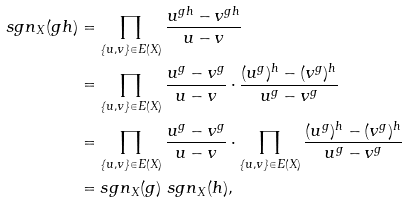Convert formula to latex. <formula><loc_0><loc_0><loc_500><loc_500>s g n _ { X } ( g h ) & = \prod _ { \{ u , v \} \in E ( X ) } \frac { u ^ { g h } - v ^ { g h } } { u - v } \\ & = \prod _ { \{ u , v \} \in E ( X ) } \frac { u ^ { g } - v ^ { g } } { u - v } \cdot \frac { ( u ^ { g } ) ^ { h } - ( v ^ { g } ) ^ { h } } { u ^ { g } - v ^ { g } } \\ & = \prod _ { \{ u , v \} \in E ( X ) } \frac { u ^ { g } - v ^ { g } } { u - v } \cdot \prod _ { \{ u , v \} \in E ( X ) } \frac { ( u ^ { g } ) ^ { h } - ( v ^ { g } ) ^ { h } } { u ^ { g } - v ^ { g } } \\ & = s g n _ { X } ( g ) \ s g n _ { X } ( h ) ,</formula> 